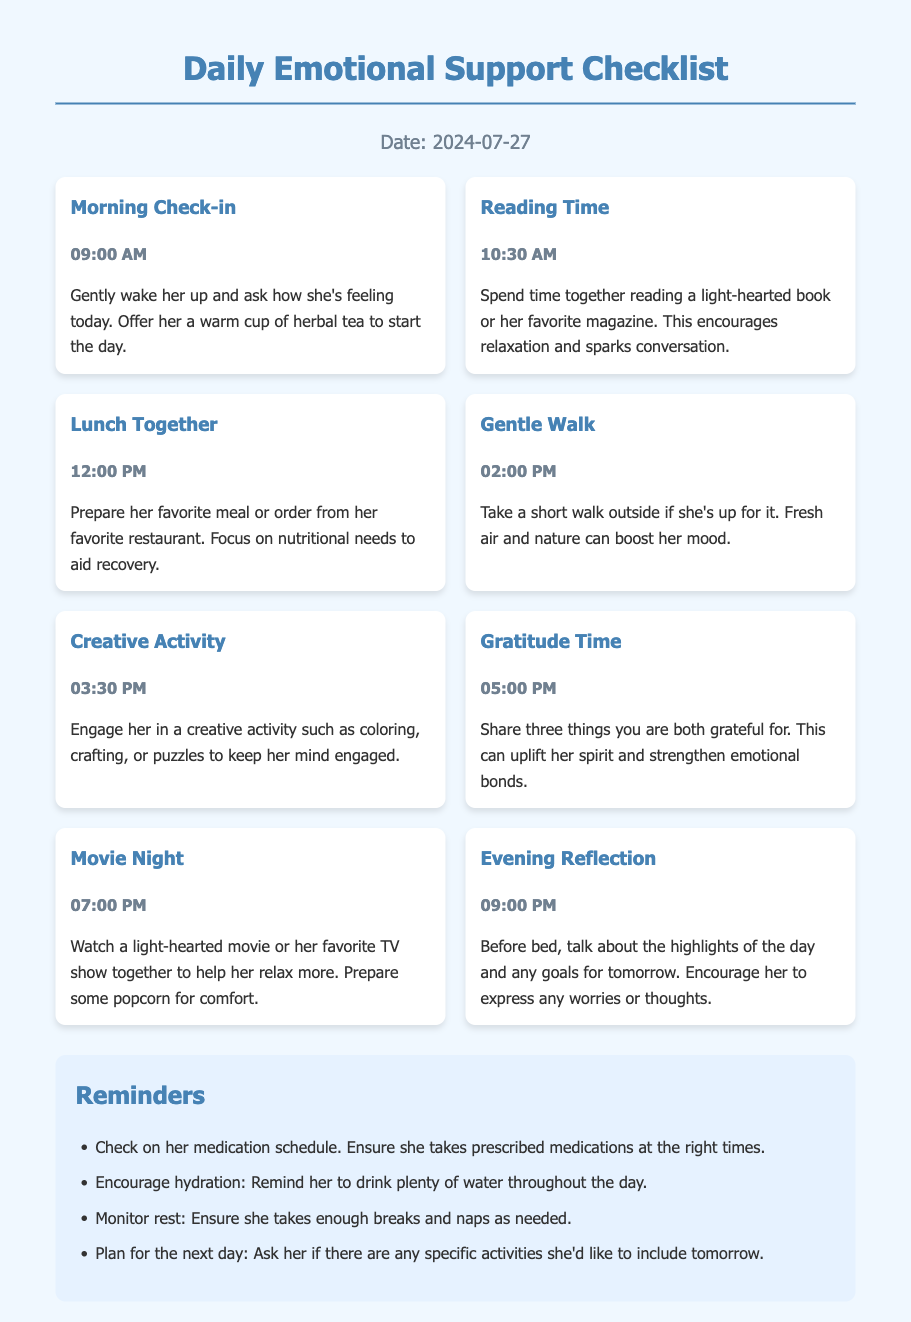what is the title of the document? The title of the document is displayed at the top, indicating its purpose and content.
Answer: Daily Emotional Support Checklist what time is suggested for the Morning Check-in? The time for the Morning Check-in is specified within the document activities.
Answer: 09:00 AM what activity is scheduled at 03:30 PM? The document enumerates activities with specific times, allowing for the identification of each activity.
Answer: Creative Activity how many things should you share during Gratitude Time? The document explicitly states the number of things to share during this activity.
Answer: Three what reminder is given regarding medication? The document includes several reminders, and one specifically mentions checking medications.
Answer: Check on her medication schedule which activity encourages discussion of the day's highlights? Each activity is designed to support emotional health, with one focused on reflecting on the day.
Answer: Evening Reflection what is the activity planned for 02:00 PM? The schedule details each activity along with the respective times.
Answer: Gentle Walk what color is used for the header of the reminders section? The document style indicates the color for headers to differentiate sections.
Answer: #4682b4 